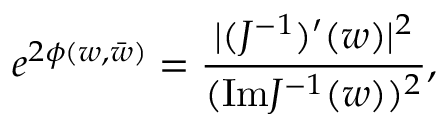<formula> <loc_0><loc_0><loc_500><loc_500>e ^ { 2 \phi ( w , \bar { w } ) } = { \frac { | ( J ^ { - 1 } ) ^ { \prime } ( w ) | ^ { 2 } } { ( I m J ^ { - 1 } ( w ) ) ^ { 2 } } } ,</formula> 